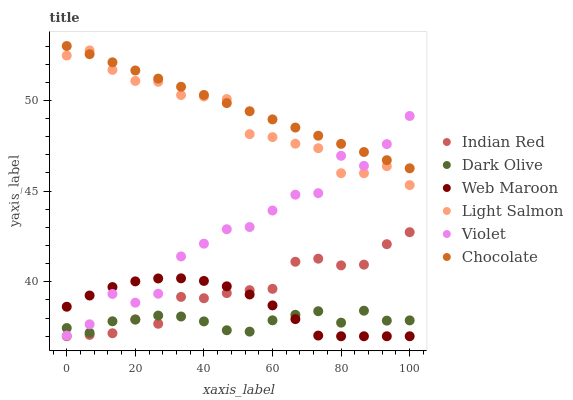Does Dark Olive have the minimum area under the curve?
Answer yes or no. Yes. Does Chocolate have the maximum area under the curve?
Answer yes or no. Yes. Does Web Maroon have the minimum area under the curve?
Answer yes or no. No. Does Web Maroon have the maximum area under the curve?
Answer yes or no. No. Is Chocolate the smoothest?
Answer yes or no. Yes. Is Violet the roughest?
Answer yes or no. Yes. Is Dark Olive the smoothest?
Answer yes or no. No. Is Dark Olive the roughest?
Answer yes or no. No. Does Web Maroon have the lowest value?
Answer yes or no. Yes. Does Dark Olive have the lowest value?
Answer yes or no. No. Does Chocolate have the highest value?
Answer yes or no. Yes. Does Web Maroon have the highest value?
Answer yes or no. No. Is Web Maroon less than Light Salmon?
Answer yes or no. Yes. Is Violet greater than Indian Red?
Answer yes or no. Yes. Does Dark Olive intersect Indian Red?
Answer yes or no. Yes. Is Dark Olive less than Indian Red?
Answer yes or no. No. Is Dark Olive greater than Indian Red?
Answer yes or no. No. Does Web Maroon intersect Light Salmon?
Answer yes or no. No. 